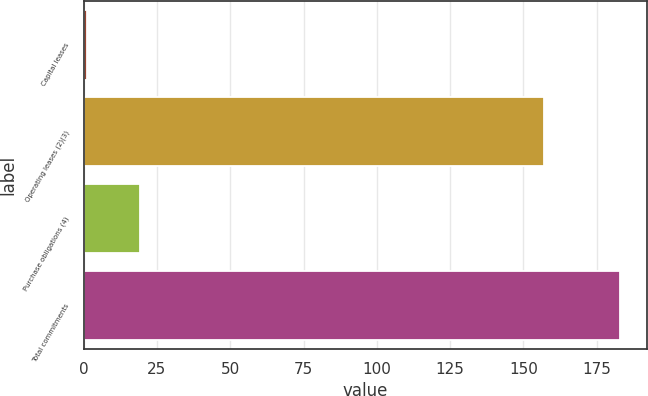Convert chart. <chart><loc_0><loc_0><loc_500><loc_500><bar_chart><fcel>Capital leases<fcel>Operating leases (2)(3)<fcel>Purchase obligations (4)<fcel>Total commitments<nl><fcel>1<fcel>157<fcel>19.2<fcel>183<nl></chart> 